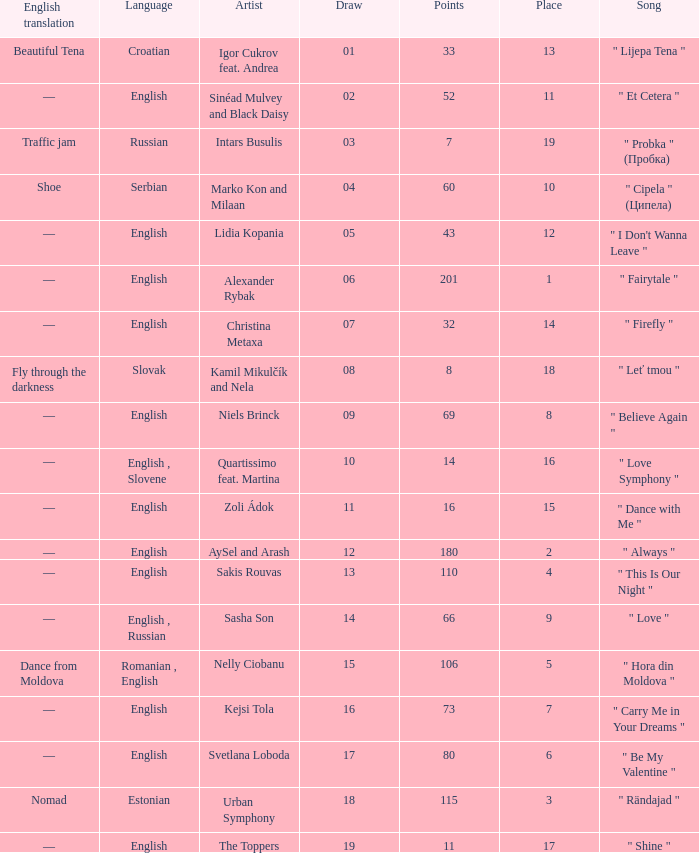What is the place when the draw is less than 12 and the artist is quartissimo feat. martina? 16.0. 